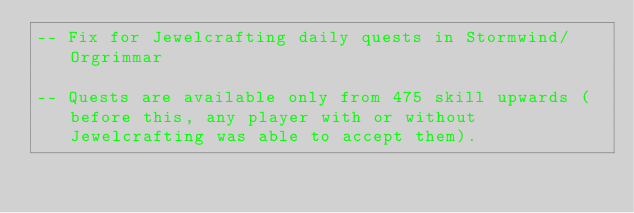Convert code to text. <code><loc_0><loc_0><loc_500><loc_500><_SQL_>-- Fix for Jewelcrafting daily quests in Stormwind/Orgrimmar

-- Quests are available only from 475 skill upwards (before this, any player with or without Jewelcrafting was able to accept them).</code> 